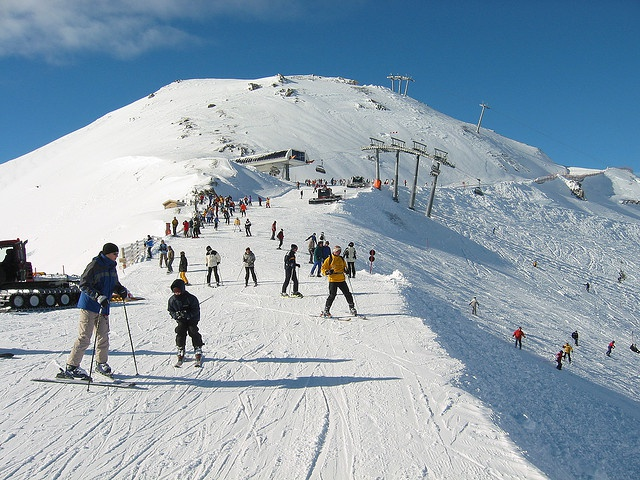Describe the objects in this image and their specific colors. I can see people in darkgray, lightgray, black, and gray tones, truck in darkgray, black, gray, and lightgray tones, people in darkgray, black, gray, and navy tones, people in darkgray, black, gray, and lightgray tones, and people in darkgray, black, olive, and gray tones in this image. 